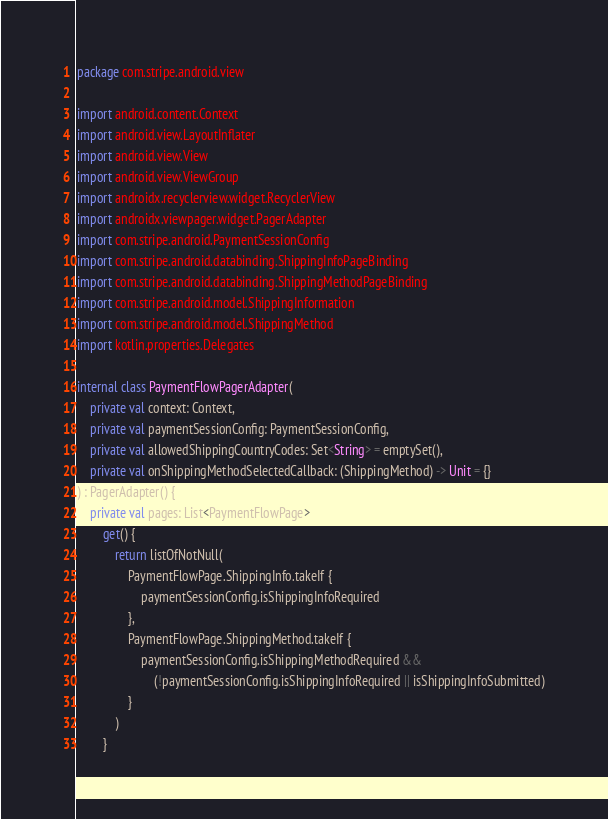Convert code to text. <code><loc_0><loc_0><loc_500><loc_500><_Kotlin_>package com.stripe.android.view

import android.content.Context
import android.view.LayoutInflater
import android.view.View
import android.view.ViewGroup
import androidx.recyclerview.widget.RecyclerView
import androidx.viewpager.widget.PagerAdapter
import com.stripe.android.PaymentSessionConfig
import com.stripe.android.databinding.ShippingInfoPageBinding
import com.stripe.android.databinding.ShippingMethodPageBinding
import com.stripe.android.model.ShippingInformation
import com.stripe.android.model.ShippingMethod
import kotlin.properties.Delegates

internal class PaymentFlowPagerAdapter(
    private val context: Context,
    private val paymentSessionConfig: PaymentSessionConfig,
    private val allowedShippingCountryCodes: Set<String> = emptySet(),
    private val onShippingMethodSelectedCallback: (ShippingMethod) -> Unit = {}
) : PagerAdapter() {
    private val pages: List<PaymentFlowPage>
        get() {
            return listOfNotNull(
                PaymentFlowPage.ShippingInfo.takeIf {
                    paymentSessionConfig.isShippingInfoRequired
                },
                PaymentFlowPage.ShippingMethod.takeIf {
                    paymentSessionConfig.isShippingMethodRequired &&
                        (!paymentSessionConfig.isShippingInfoRequired || isShippingInfoSubmitted)
                }
            )
        }
</code> 